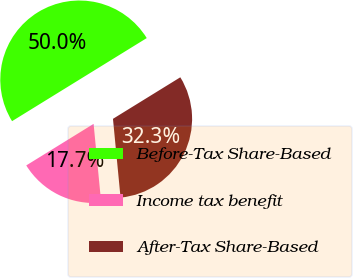Convert chart to OTSL. <chart><loc_0><loc_0><loc_500><loc_500><pie_chart><fcel>Before-Tax Share-Based<fcel>Income tax benefit<fcel>After-Tax Share-Based<nl><fcel>50.0%<fcel>17.73%<fcel>32.27%<nl></chart> 